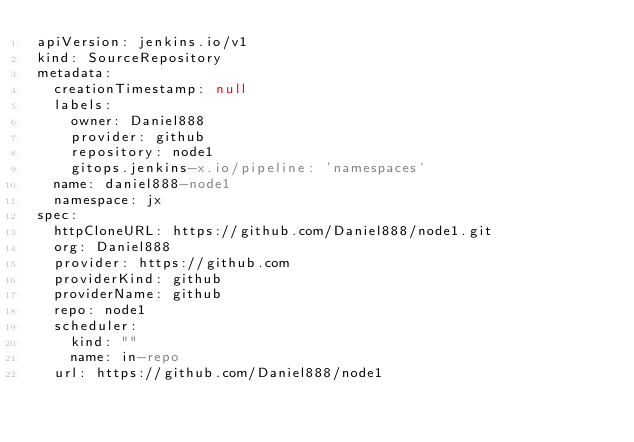Convert code to text. <code><loc_0><loc_0><loc_500><loc_500><_YAML_>apiVersion: jenkins.io/v1
kind: SourceRepository
metadata:
  creationTimestamp: null
  labels:
    owner: Daniel888
    provider: github
    repository: node1
    gitops.jenkins-x.io/pipeline: 'namespaces'
  name: daniel888-node1
  namespace: jx
spec:
  httpCloneURL: https://github.com/Daniel888/node1.git
  org: Daniel888
  provider: https://github.com
  providerKind: github
  providerName: github
  repo: node1
  scheduler:
    kind: ""
    name: in-repo
  url: https://github.com/Daniel888/node1
</code> 